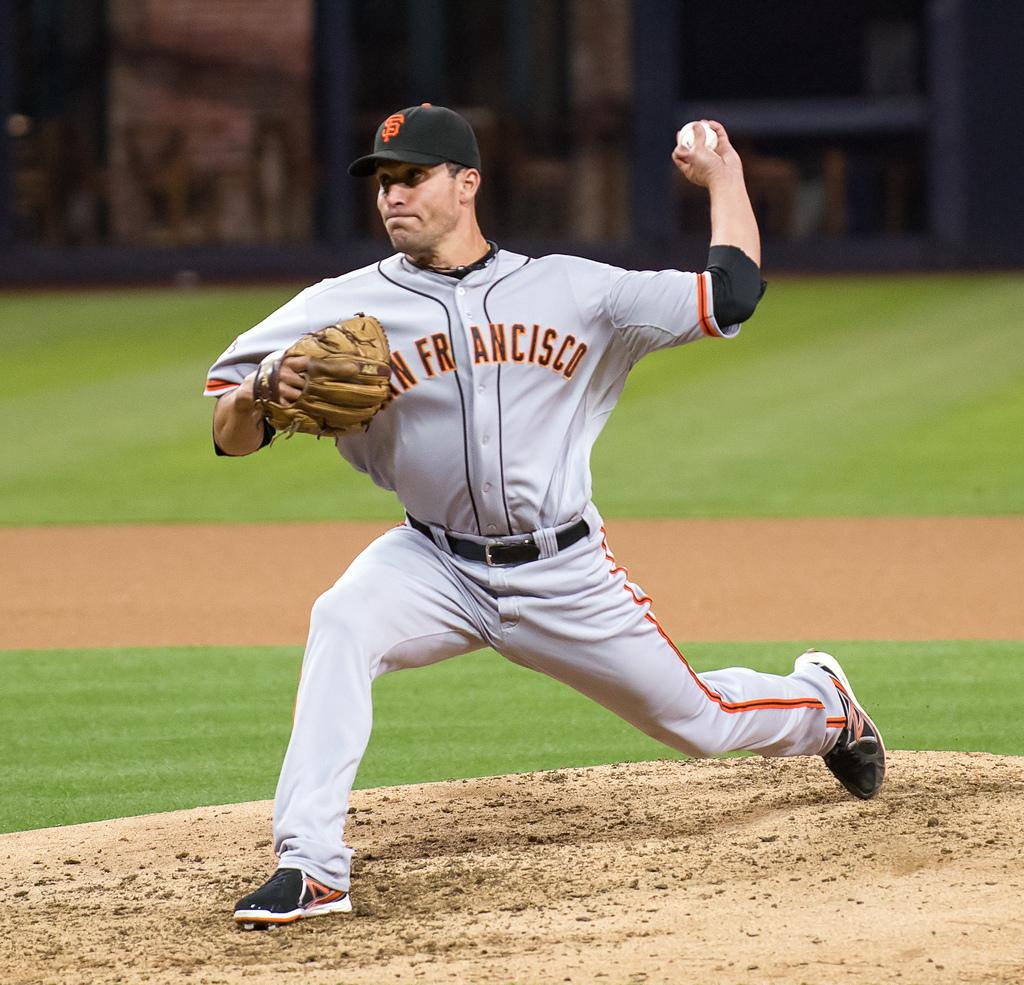What team does he play for?
Your answer should be very brief. San francisco. What letter is on this player's shoe in red?
Provide a short and direct response. N. 